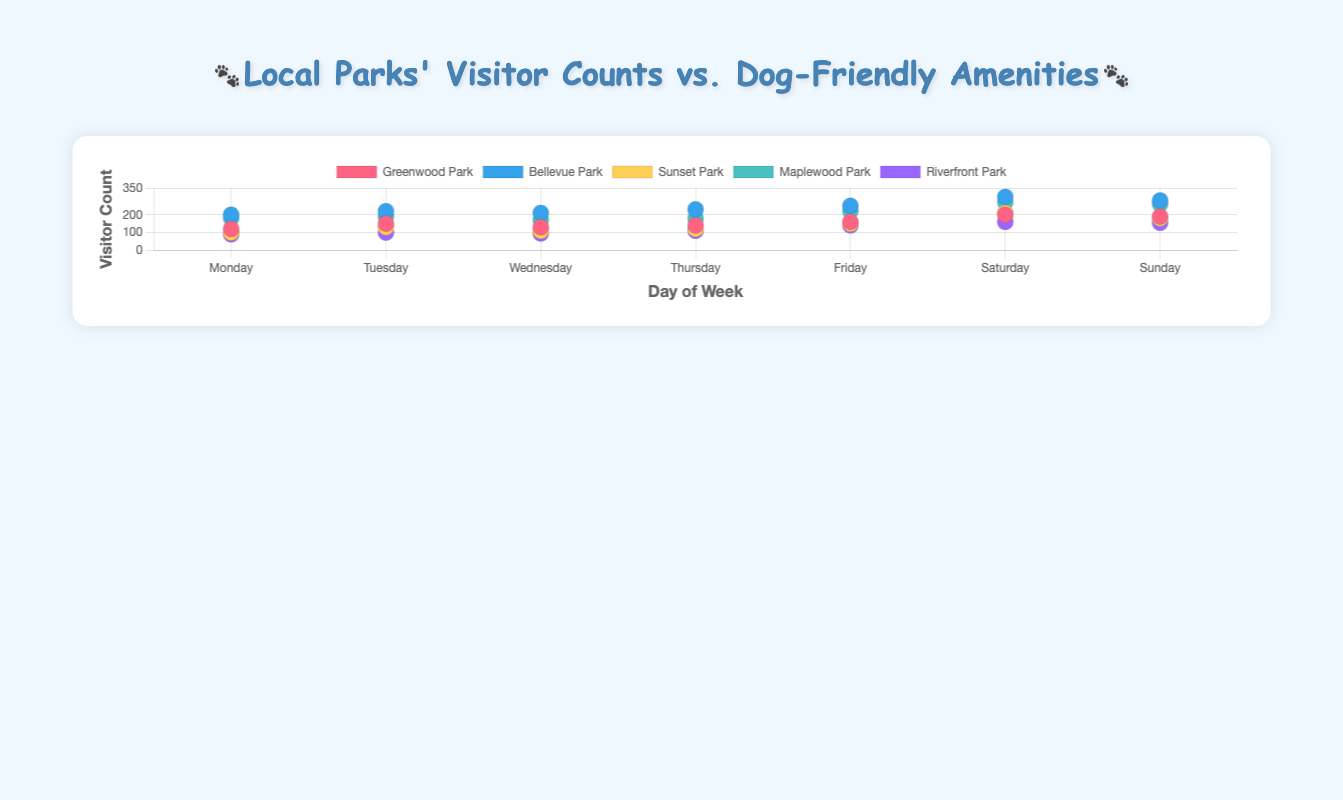What's the most visited park on Saturday? Look for the park with the highest y-value on the day corresponding to Saturday. Bellevue Park has the highest point on Saturday with a visitor count of 300.
Answer: Bellevue Park How many amenities does Maplewood Park have? Examine the tooltip or legend associated with Maplewood Park to find the listed amenities. Maplewood Park has "Water Fountains" and "Dog Waste Stations" which makes a total of 2 amenities.
Answer: 2 Which park has the fewest visitors on Monday? Compare the y-values of all parks for Monday. Riverfront Park has the smallest value with 90 visitors.
Answer: Riverfront Park What's the total number of visitors at Bellevue Park from Monday to Thursday? Sum the visitor counts for Bellevue Park from Monday to Thursday (200 + 220 + 210 + 230). The total is 860.
Answer: 860 Which day has the overall highest visitor count for Greenwood Park? Identify the highest y-value for Greenwood Park across all days. On Saturday, Greenwood Park has the highest visitor count of 200.
Answer: Saturday How do the visitor counts between Greenwood Park and Sunset Park compare on Tuesday? Observe the y-values for both parks on Tuesday. Greenwood Park has 150 visitors while Sunset Park has 130. Greenwood Park has 20 more visitors than Sunset Park on Tuesday.
Answer: Greenwood Park has more visitors If you average the visitor counts of Maplewood Park on weekdays (Monday to Friday), what would it be? Sum the visitor counts from Monday to Friday (180 + 190 + 170 + 180 + 220) and divide by 5. This gives an average of (180 + 190 + 170 + 180 + 220) / 5 = 188.
Answer: 188 Which park has the widest range in visitor counts across the week? Calculate the difference between the maximum and minimum visitor counts for each park. Bellevue Park has the widest range: 300 - 200 = 100.
Answer: Bellevue Park Do parks with more amenities generally have higher visitor counts on weekends? Examine parks with multiple amenities and compare their weekend visitor counts. Parks with 3 amenities (Greenwood Park and Riverfront Park) do not necessarily have higher visitor counts compared to parks with fewer amenities (Bellevue Park).
Answer: No clear correlation 